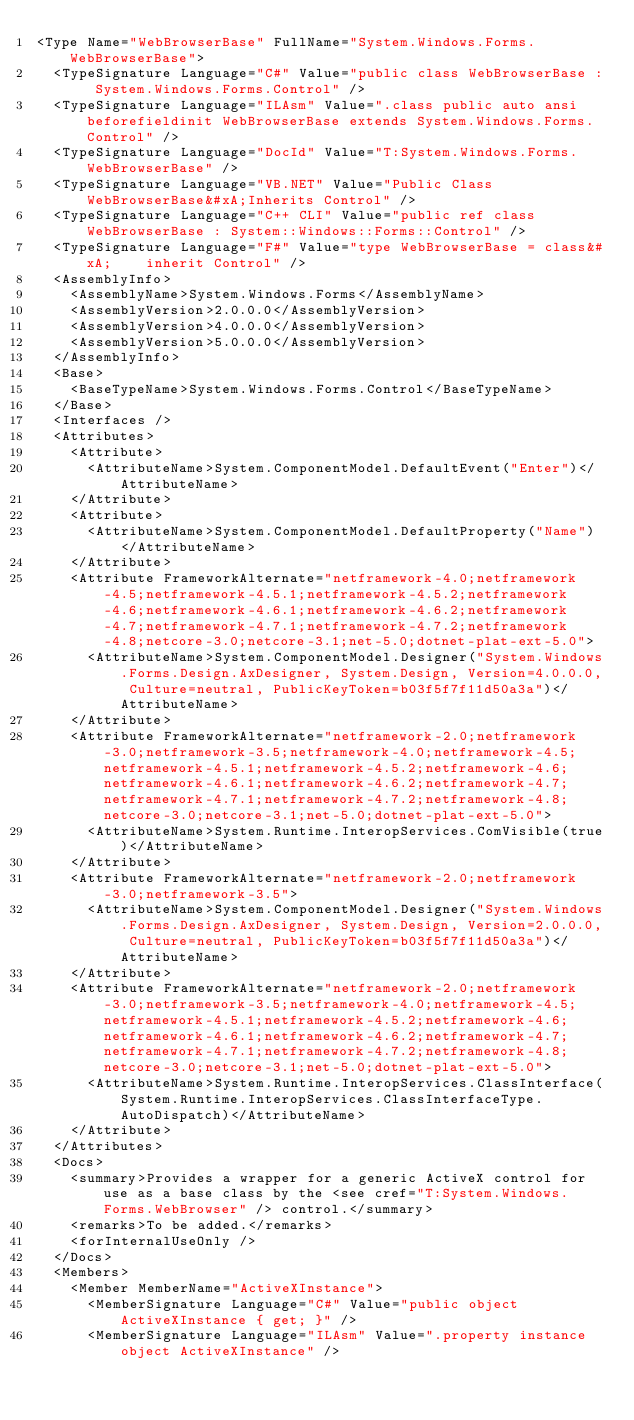Convert code to text. <code><loc_0><loc_0><loc_500><loc_500><_XML_><Type Name="WebBrowserBase" FullName="System.Windows.Forms.WebBrowserBase">
  <TypeSignature Language="C#" Value="public class WebBrowserBase : System.Windows.Forms.Control" />
  <TypeSignature Language="ILAsm" Value=".class public auto ansi beforefieldinit WebBrowserBase extends System.Windows.Forms.Control" />
  <TypeSignature Language="DocId" Value="T:System.Windows.Forms.WebBrowserBase" />
  <TypeSignature Language="VB.NET" Value="Public Class WebBrowserBase&#xA;Inherits Control" />
  <TypeSignature Language="C++ CLI" Value="public ref class WebBrowserBase : System::Windows::Forms::Control" />
  <TypeSignature Language="F#" Value="type WebBrowserBase = class&#xA;    inherit Control" />
  <AssemblyInfo>
    <AssemblyName>System.Windows.Forms</AssemblyName>
    <AssemblyVersion>2.0.0.0</AssemblyVersion>
    <AssemblyVersion>4.0.0.0</AssemblyVersion>
    <AssemblyVersion>5.0.0.0</AssemblyVersion>
  </AssemblyInfo>
  <Base>
    <BaseTypeName>System.Windows.Forms.Control</BaseTypeName>
  </Base>
  <Interfaces />
  <Attributes>
    <Attribute>
      <AttributeName>System.ComponentModel.DefaultEvent("Enter")</AttributeName>
    </Attribute>
    <Attribute>
      <AttributeName>System.ComponentModel.DefaultProperty("Name")</AttributeName>
    </Attribute>
    <Attribute FrameworkAlternate="netframework-4.0;netframework-4.5;netframework-4.5.1;netframework-4.5.2;netframework-4.6;netframework-4.6.1;netframework-4.6.2;netframework-4.7;netframework-4.7.1;netframework-4.7.2;netframework-4.8;netcore-3.0;netcore-3.1;net-5.0;dotnet-plat-ext-5.0">
      <AttributeName>System.ComponentModel.Designer("System.Windows.Forms.Design.AxDesigner, System.Design, Version=4.0.0.0, Culture=neutral, PublicKeyToken=b03f5f7f11d50a3a")</AttributeName>
    </Attribute>
    <Attribute FrameworkAlternate="netframework-2.0;netframework-3.0;netframework-3.5;netframework-4.0;netframework-4.5;netframework-4.5.1;netframework-4.5.2;netframework-4.6;netframework-4.6.1;netframework-4.6.2;netframework-4.7;netframework-4.7.1;netframework-4.7.2;netframework-4.8;netcore-3.0;netcore-3.1;net-5.0;dotnet-plat-ext-5.0">
      <AttributeName>System.Runtime.InteropServices.ComVisible(true)</AttributeName>
    </Attribute>
    <Attribute FrameworkAlternate="netframework-2.0;netframework-3.0;netframework-3.5">
      <AttributeName>System.ComponentModel.Designer("System.Windows.Forms.Design.AxDesigner, System.Design, Version=2.0.0.0, Culture=neutral, PublicKeyToken=b03f5f7f11d50a3a")</AttributeName>
    </Attribute>
    <Attribute FrameworkAlternate="netframework-2.0;netframework-3.0;netframework-3.5;netframework-4.0;netframework-4.5;netframework-4.5.1;netframework-4.5.2;netframework-4.6;netframework-4.6.1;netframework-4.6.2;netframework-4.7;netframework-4.7.1;netframework-4.7.2;netframework-4.8;netcore-3.0;netcore-3.1;net-5.0;dotnet-plat-ext-5.0">
      <AttributeName>System.Runtime.InteropServices.ClassInterface(System.Runtime.InteropServices.ClassInterfaceType.AutoDispatch)</AttributeName>
    </Attribute>
  </Attributes>
  <Docs>
    <summary>Provides a wrapper for a generic ActiveX control for use as a base class by the <see cref="T:System.Windows.Forms.WebBrowser" /> control.</summary>
    <remarks>To be added.</remarks>
    <forInternalUseOnly />
  </Docs>
  <Members>
    <Member MemberName="ActiveXInstance">
      <MemberSignature Language="C#" Value="public object ActiveXInstance { get; }" />
      <MemberSignature Language="ILAsm" Value=".property instance object ActiveXInstance" /></code> 